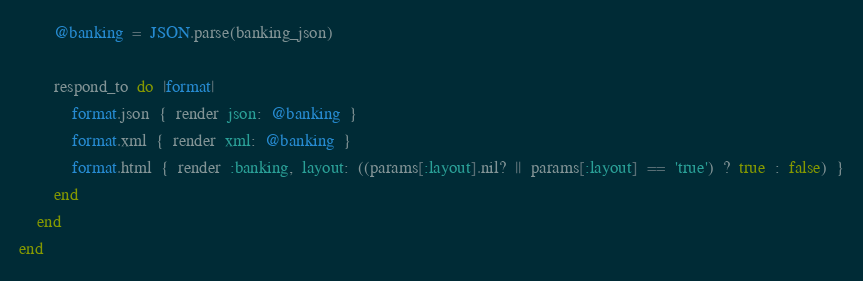<code> <loc_0><loc_0><loc_500><loc_500><_Ruby_>        @banking  =  JSON.parse(banking_json)

        respond_to  do  |format|
            format.json  {  render  json:  @banking  }
            format.xml  {  render  xml:  @banking  }
            format.html  {  render  :banking,  layout:  ((params[:layout].nil?  ||  params[:layout]  ==  'true')  ?  true  :  false)  }
        end
    end
end
</code> 